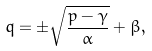Convert formula to latex. <formula><loc_0><loc_0><loc_500><loc_500>q = \pm \sqrt { \frac { p - \gamma } { \alpha } } + \beta ,</formula> 